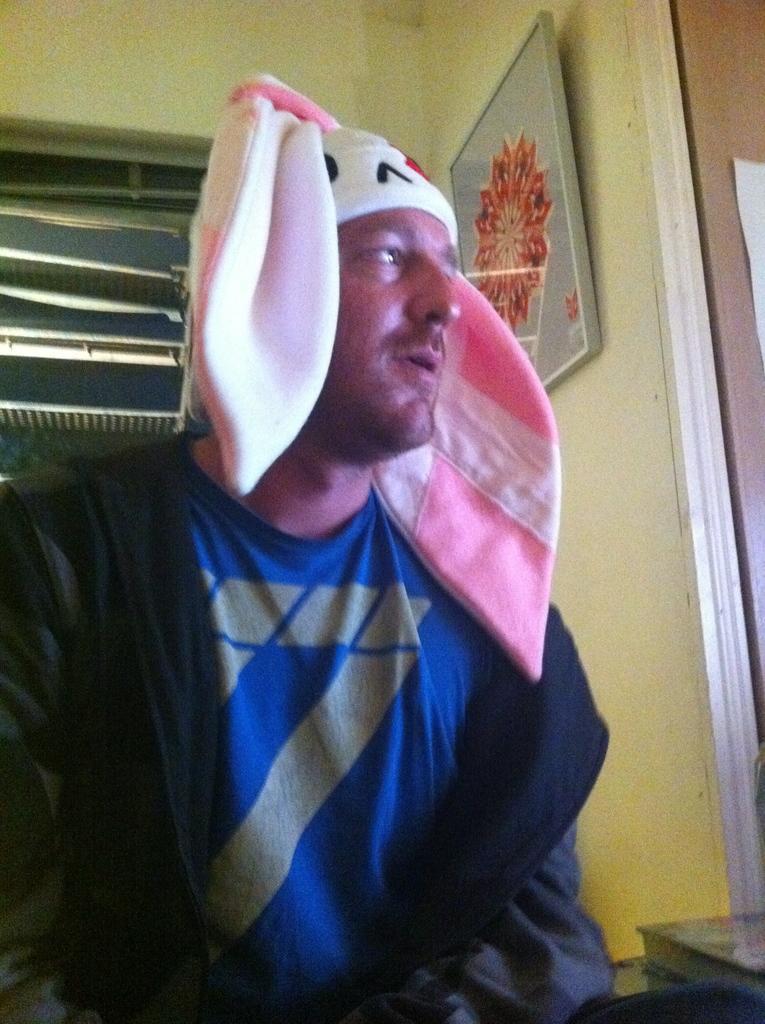Describe this image in one or two sentences. In this image we can see a man wearing the cap. In the background we can see the ventilation and also a frame attached to the plain wall. We can also see the paper. 